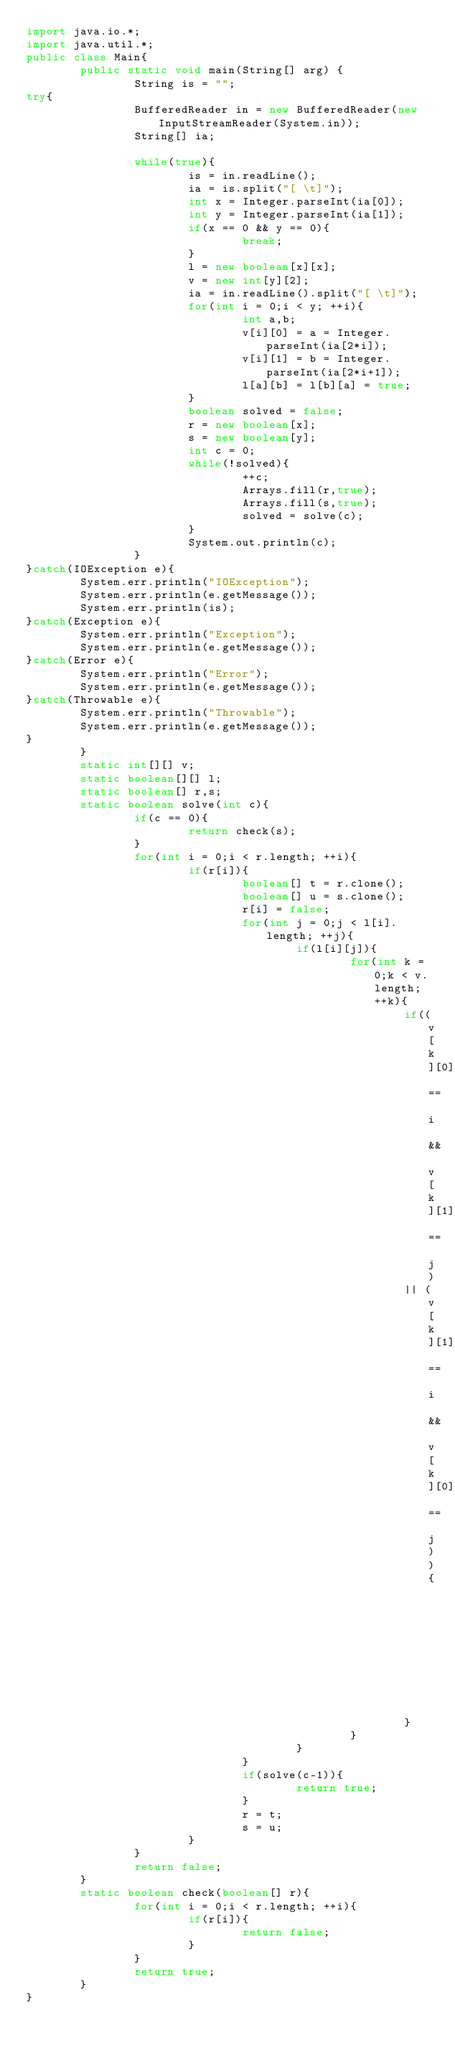Convert code to text. <code><loc_0><loc_0><loc_500><loc_500><_Java_>import java.io.*;
import java.util.*;
public class Main{
        public static void main(String[] arg) {
                String is = "";
try{
                BufferedReader in = new BufferedReader(new InputStreamReader(System.in));
                String[] ia;

                while(true){
                        is = in.readLine();
                        ia = is.split("[ \t]");
                        int x = Integer.parseInt(ia[0]);
                        int y = Integer.parseInt(ia[1]);
                        if(x == 0 && y == 0){
                                break;
                        }
                        l = new boolean[x][x];
                        v = new int[y][2];
                        ia = in.readLine().split("[ \t]");
                        for(int i = 0;i < y; ++i){
                                int a,b;
                                v[i][0] = a = Integer.parseInt(ia[2*i]);
                                v[i][1] = b = Integer.parseInt(ia[2*i+1]);
                                l[a][b] = l[b][a] = true;
                        }
                        boolean solved = false;
                        r = new boolean[x];
                        s = new boolean[y];
                        int c = 0;
                        while(!solved){
                                ++c;
                                Arrays.fill(r,true);
                                Arrays.fill(s,true);
                                solved = solve(c);
                        }
                        System.out.println(c);
                }
}catch(IOException e){
        System.err.println("IOException");
        System.err.println(e.getMessage());
        System.err.println(is);
}catch(Exception e){
        System.err.println("Exception");
        System.err.println(e.getMessage());
}catch(Error e){
        System.err.println("Error");
        System.err.println(e.getMessage());
}catch(Throwable e){
        System.err.println("Throwable");
        System.err.println(e.getMessage());
}
        }
        static int[][] v;
        static boolean[][] l;
        static boolean[] r,s;
        static boolean solve(int c){
                if(c == 0){
                        return check(s);
                }
                for(int i = 0;i < r.length; ++i){
                        if(r[i]){
                                boolean[] t = r.clone();
                                boolean[] u = s.clone();
                                r[i] = false;
                                for(int j = 0;j < l[i].length; ++j){
                                        if(l[i][j]){
                                                for(int k = 0;k < v.length; ++k){
                                                        if((v[k][0] == i && v[k][1] == j)
                                                        || (v[k][1] == i && v[k][0] == j)){
                                                                s[k] = false;
                                                        }
                                                }
                                        }
                                }
                                if(solve(c-1)){
                                        return true;
                                }
                                r = t;
                                s = u;
                        }
                }
                return false;
        }
        static boolean check(boolean[] r){
                for(int i = 0;i < r.length; ++i){
                        if(r[i]){
                                return false;
                        }
                }
                return true;
        }
}</code> 